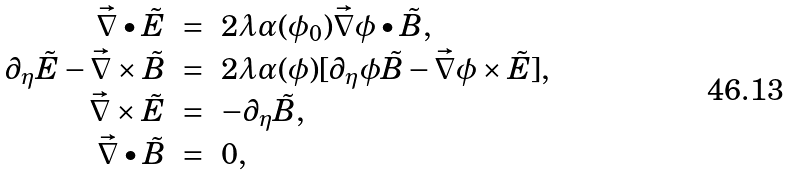<formula> <loc_0><loc_0><loc_500><loc_500>\begin{array} { r r l } \vec { \nabla } \bullet \tilde { E } & = & 2 \lambda \alpha ( \phi _ { 0 } ) \vec { \nabla } \phi \bullet \tilde { B } , \\ \partial _ { \eta } \tilde { E } - \vec { \nabla } \times \tilde { B } & = & 2 \lambda \alpha ( \phi ) [ \partial _ { \eta } \phi \tilde { B } - \vec { \nabla } \phi \times \tilde { E } ] , \\ \vec { \nabla } \times \tilde { E } & = & - \partial _ { \eta } \tilde { B } , \\ \vec { \nabla } \bullet \tilde { B } & = & 0 , \end{array}</formula> 